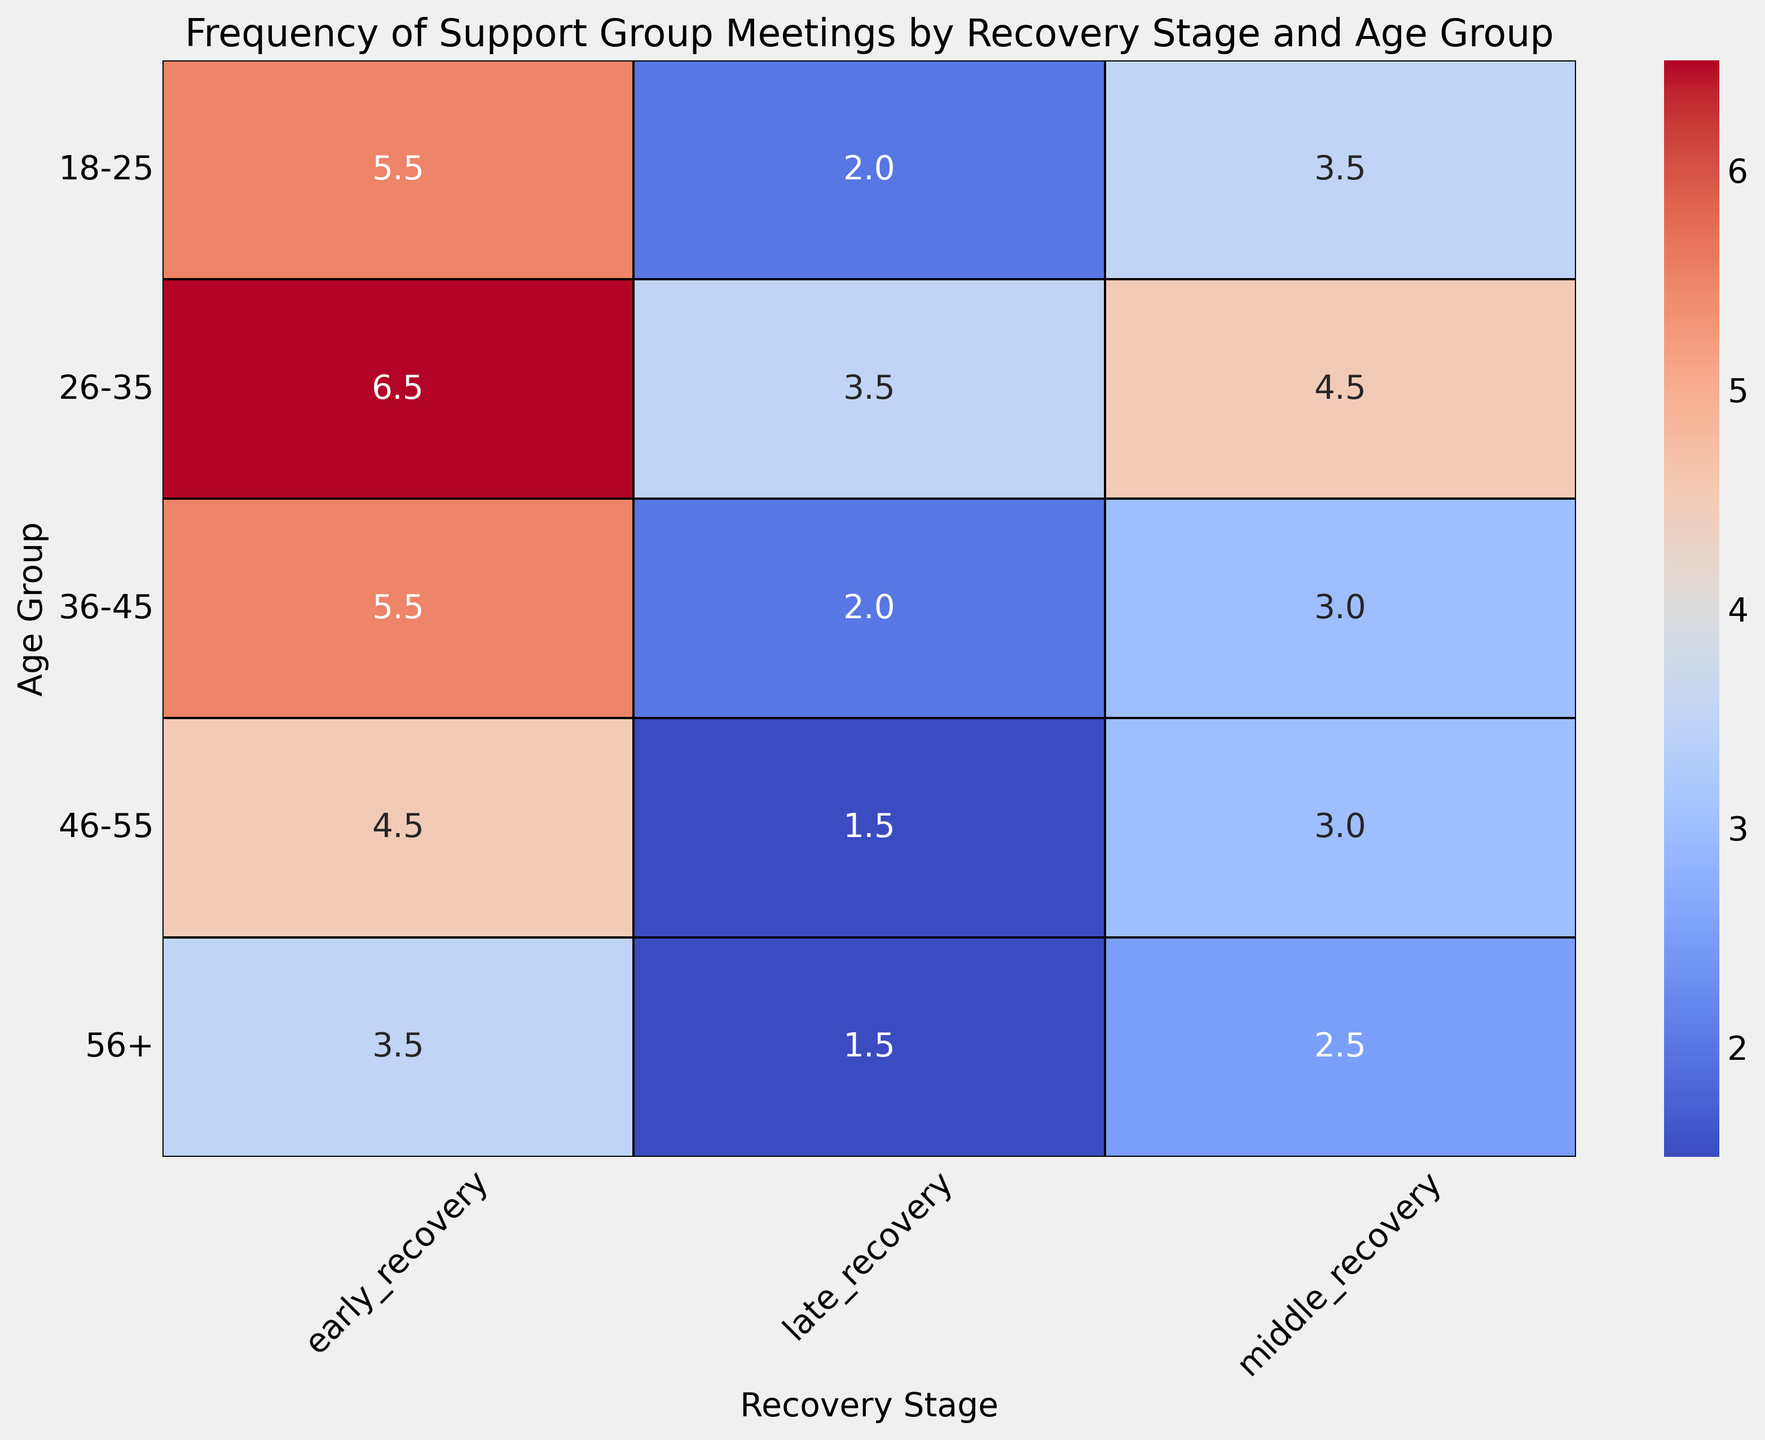What is the average number of meetings per week for the 26-35 age group across all recovery stages? To find the average, sum the number of meetings per week for each recovery stage in 26-35 and divide by the number of stages. The numbers are 6, 4, and 3, giving (6 + 4 + 3) / 3 = 13 / 3 = 4.3.
Answer: 4.3 Which age group has the highest average number of meetings per week during the early recovery stage? Look at the early recovery stage column and identify the maximum value. The highest number is 6, which corresponds to the 26-35 age group.
Answer: 26-35 How much higher is the average number of meetings per week in early recovery compared to late recovery for the 18-25 age group? Subtract the average number of meetings in late recovery from early recovery for the 18-25 age group. The values are 5 and 2 respectively, giving 5 - 2 = 3.
Answer: 3 Do older age groups (46-55 and 56+) generally attend fewer meetings than younger age groups (18-25 and 26-35) in the late recovery stage? Compare the values in the late recovery column for the specified age groups. 46-55 and 56+ have values of 1 and 2, respectively, while 18-25 and 26-35 have values of 2 and 3, respectively. The older groups (1 and 2) do attend fewer meetings than the younger groups (2 and 3).
Answer: Yes What is the total number of meetings per week attended by the 36-45 age group across all recovery stages? Sum the number of meetings per week for each recovery stage in 36-45. The values are 5, 3, and 2 giving 5 + 3 + 2 = 10.
Answer: 10 Compare the average number of meetings per week between early recovery stages for the 18-25 and 36-45 age groups. Which is higher? The early recovery values for 18-25 and 36-45 are 5 and 6 respectively. Since 6 is greater than 5, 36-45 has a higher average number of meetings.
Answer: 36-45 What pattern can you observe about the frequency of meetings as the recovery stage progresses in the 56+ age group? Observe the trend in the 56+ age group across recovery stages. The values are 4, 3, and 2, indicating a decreasing pattern as recovery progresses.
Answer: Decreasing Is there an age group where the number of meetings per week does not change between middle and late recovery stages? Look for age groups where the middle and late recovery values are equal. The 36-45 age group has the same value (3) in middle and late recovery.
Answer: 36-45 How does the number of meetings per week in middle recovery for 46-55 compare to that in middle recovery for 26-35? Compare the values in the middle recovery stage for both age groups. The values are 3 for 46-55 and 5 for 26-35, so 46-55 attends fewer meetings.
Answer: 46-55 has fewer meetings What is the visual pattern observed in the heatmap for the late recovery stage across age groups? Observe the color and numeric values for the late recovery stage. The pattern shows the number of meetings decreasing as the age increases from 3 for 26-35 to 1 for 46-55, indicating a downward trend.
Answer: Decreasing 